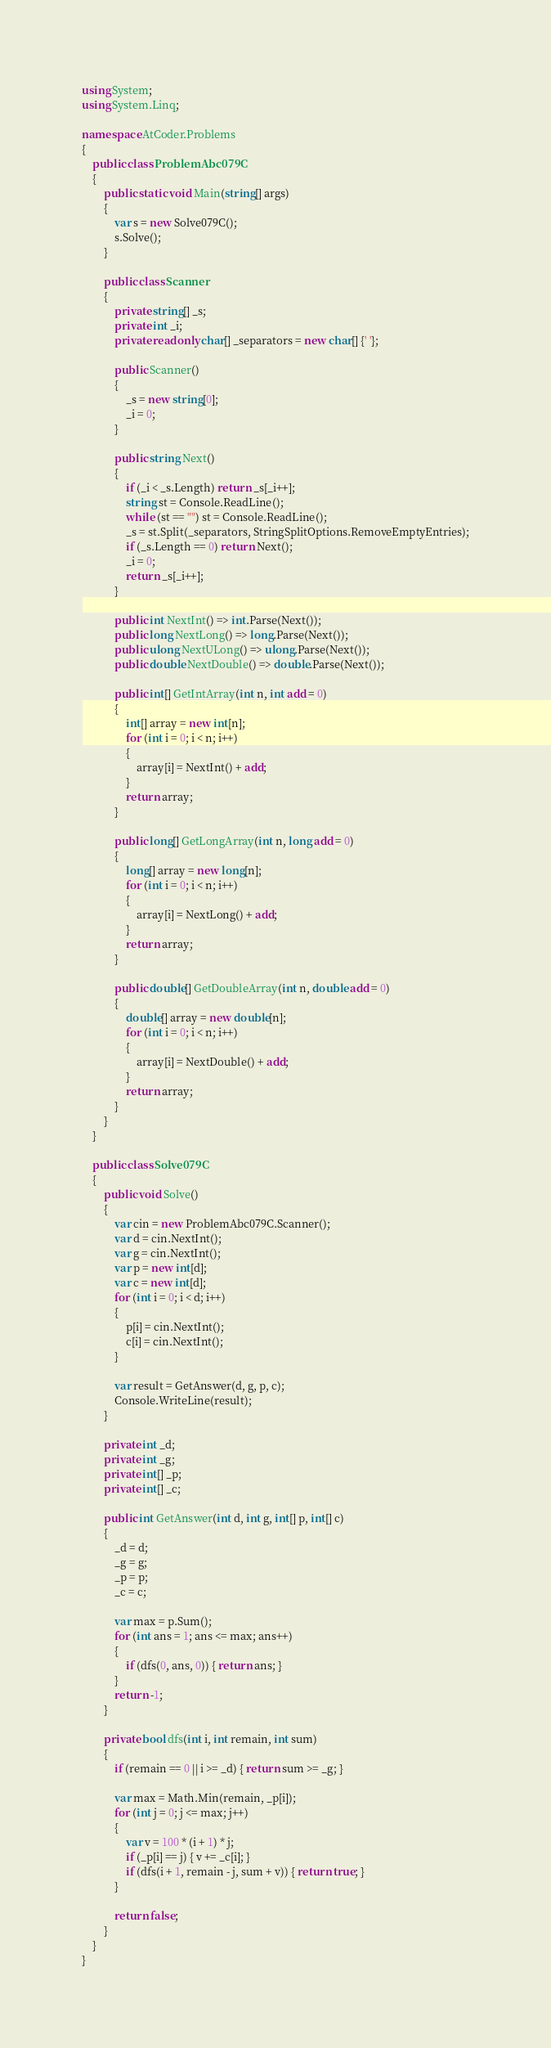<code> <loc_0><loc_0><loc_500><loc_500><_C#_>using System;
using System.Linq;

namespace AtCoder.Problems
{
    public class ProblemAbc079C
    {
        public static void Main(string[] args)
        {
            var s = new Solve079C();
            s.Solve();
        }

        public class Scanner
        {
            private string[] _s;
            private int _i;
            private readonly char[] _separators = new char[] {' '};

            public Scanner()
            {
                _s = new string[0];
                _i = 0;
            }

            public string Next()
            {
                if (_i < _s.Length) return _s[_i++];
                string st = Console.ReadLine();
                while (st == "") st = Console.ReadLine();
                _s = st.Split(_separators, StringSplitOptions.RemoveEmptyEntries);
                if (_s.Length == 0) return Next();
                _i = 0;
                return _s[_i++];
            }

            public int NextInt() => int.Parse(Next());
            public long NextLong() => long.Parse(Next());
            public ulong NextULong() => ulong.Parse(Next());
            public double NextDouble() => double.Parse(Next());

            public int[] GetIntArray(int n, int add = 0)
            {
                int[] array = new int[n];
                for (int i = 0; i < n; i++)
                {
                    array[i] = NextInt() + add;
                }
                return array;
            }

            public long[] GetLongArray(int n, long add = 0)
            {
                long[] array = new long[n];
                for (int i = 0; i < n; i++)
                {
                    array[i] = NextLong() + add;
                }
                return array;
            }

            public double[] GetDoubleArray(int n, double add = 0)
            {
                double[] array = new double[n];
                for (int i = 0; i < n; i++)
                {
                    array[i] = NextDouble() + add;
                }
                return array;
            }
        }
    }

    public class Solve079C
    {
        public void Solve()
        {
            var cin = new ProblemAbc079C.Scanner();
            var d = cin.NextInt();
            var g = cin.NextInt();
            var p = new int[d];
            var c = new int[d];
            for (int i = 0; i < d; i++)
            {
                p[i] = cin.NextInt();
                c[i] = cin.NextInt();
            }

            var result = GetAnswer(d, g, p, c);
            Console.WriteLine(result);
        }

        private int _d;
        private int _g;
        private int[] _p;
        private int[] _c;

        public int GetAnswer(int d, int g, int[] p, int[] c)
        {
            _d = d;
            _g = g;
            _p = p;
            _c = c;

            var max = p.Sum();
            for (int ans = 1; ans <= max; ans++)
            {
                if (dfs(0, ans, 0)) { return ans; }
            }
            return -1;
        }

        private bool dfs(int i, int remain, int sum)
        {
            if (remain == 0 || i >= _d) { return sum >= _g; }

            var max = Math.Min(remain, _p[i]);
            for (int j = 0; j <= max; j++)
            {
                var v = 100 * (i + 1) * j;
                if (_p[i] == j) { v += _c[i]; }
                if (dfs(i + 1, remain - j, sum + v)) { return true; }
            }

            return false;
        }
    }
}
</code> 